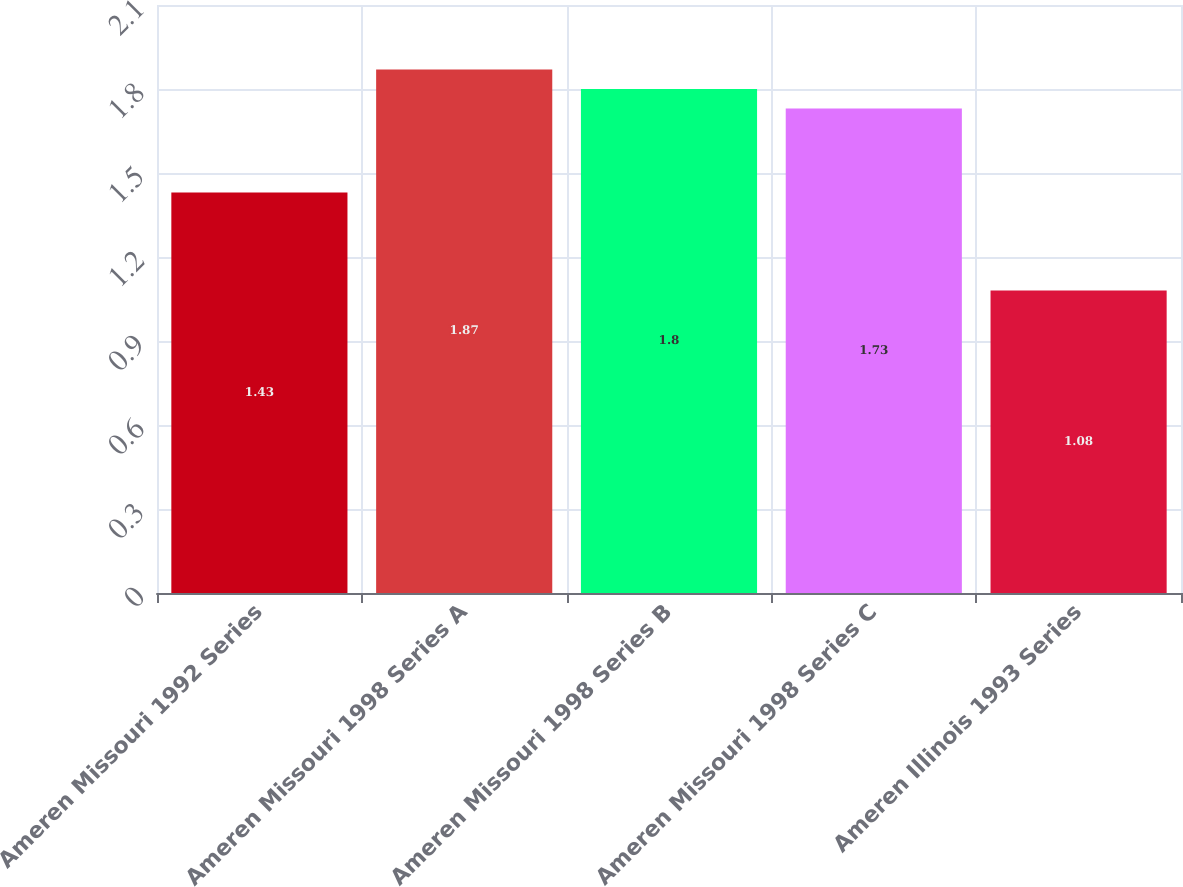Convert chart. <chart><loc_0><loc_0><loc_500><loc_500><bar_chart><fcel>Ameren Missouri 1992 Series<fcel>Ameren Missouri 1998 Series A<fcel>Ameren Missouri 1998 Series B<fcel>Ameren Missouri 1998 Series C<fcel>Ameren Illinois 1993 Series<nl><fcel>1.43<fcel>1.87<fcel>1.8<fcel>1.73<fcel>1.08<nl></chart> 